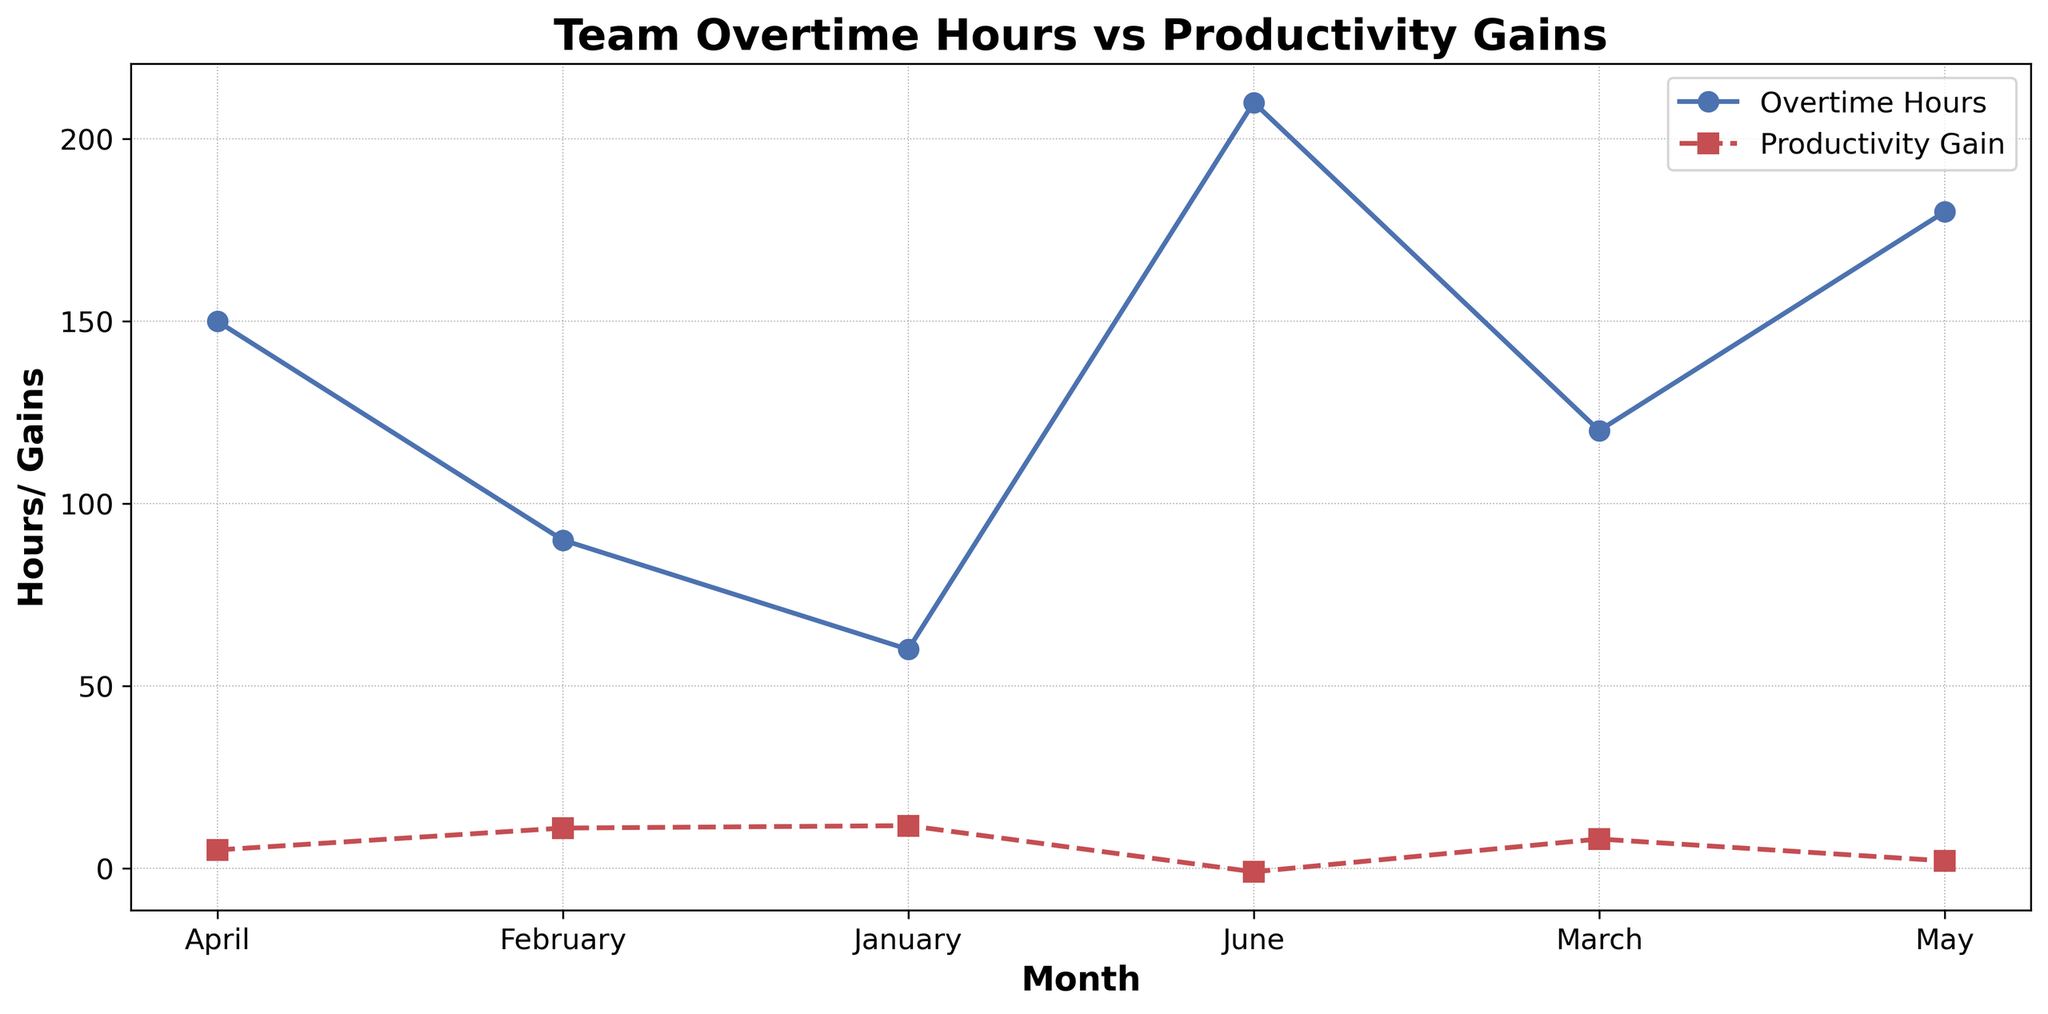What is the trend of Team Overtime Hours from January to June? Observe the blue line in the figure. It increases steadily from January to June. This indicates that the Team Overtime Hours are consistently rising each month.
Answer: Increasing What is the trend of Productivity Gains from January to June? Observe the red line in the figure. It starts at 13 in January and drops to -2 in June, indicating a consistent decrease over the months.
Answer: Decreasing In which month did the Team Overtime Hours reach 200? Look for the blue line and note where it intersects with 200 on the y-axis. It intersects in June.
Answer: June In which month is the highest Productivity Gain observed, and what is its value? Check the red line for the highest point, which occurs in January with a value of 13.
Answer: January, 13 By how much did the Productivity Gain decrease from February to March? The Productivity Gain in February is 10, and in March, it is 7. The decrease is 10 - 7 = 3.
Answer: 3 What is the difference between Team Overtime Hours and Productivity Gain in April? In April, Team Overtime Hours are around 150, and Productivity Gain is 5. The difference is 150 - 5 = 145.
Answer: 145 Is there any month where both Team Overtime Hours and Productivity Gain decreased compared to the previous month? Compare the values for each month. From March to April, Team Overtime Hours increased from 130 to 140, and Productivity Gain decreased from 7 to 6. Thus, no month shows both metrics decreasing.
Answer: No Which month shows the sharpest decline in Productivity Gain compared to its previous month? By comparing reductions, the largest drop occurs from May (Productivity Gain 1) to June (-2), a drop of 1 - (-2) = 3.
Answer: June Which month has the smallest difference between Team Overtime Hours and Productivity Gain? Calculate the differences for each month: January (50 - 13 = 37), February (80 - 10 = 70), March (110 - 7 = 103), April (140 - 5 = 135), May (170 - 1 = 169), June (200 - (-2) = 202). The smallest difference is in January, with 37.
Answer: January 